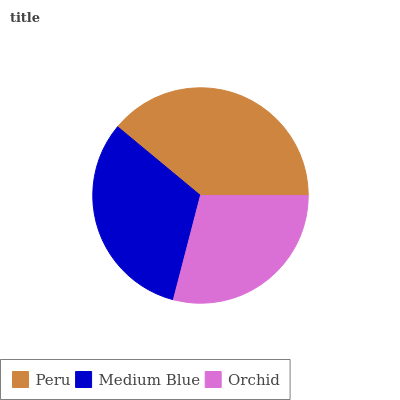Is Orchid the minimum?
Answer yes or no. Yes. Is Peru the maximum?
Answer yes or no. Yes. Is Medium Blue the minimum?
Answer yes or no. No. Is Medium Blue the maximum?
Answer yes or no. No. Is Peru greater than Medium Blue?
Answer yes or no. Yes. Is Medium Blue less than Peru?
Answer yes or no. Yes. Is Medium Blue greater than Peru?
Answer yes or no. No. Is Peru less than Medium Blue?
Answer yes or no. No. Is Medium Blue the high median?
Answer yes or no. Yes. Is Medium Blue the low median?
Answer yes or no. Yes. Is Orchid the high median?
Answer yes or no. No. Is Orchid the low median?
Answer yes or no. No. 